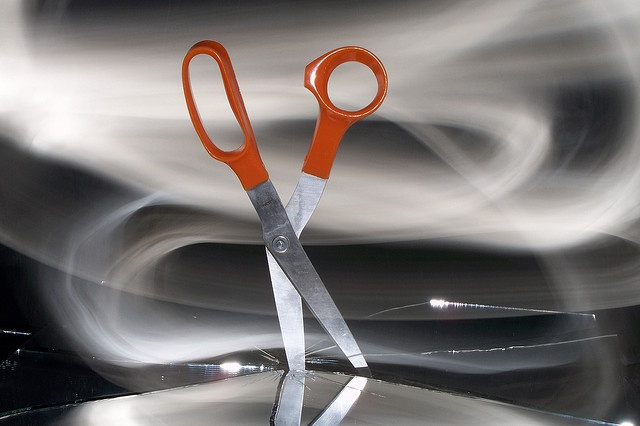Describe the objects in this image and their specific colors. I can see scissors in darkgray, lightgray, gray, and brown tones in this image. 